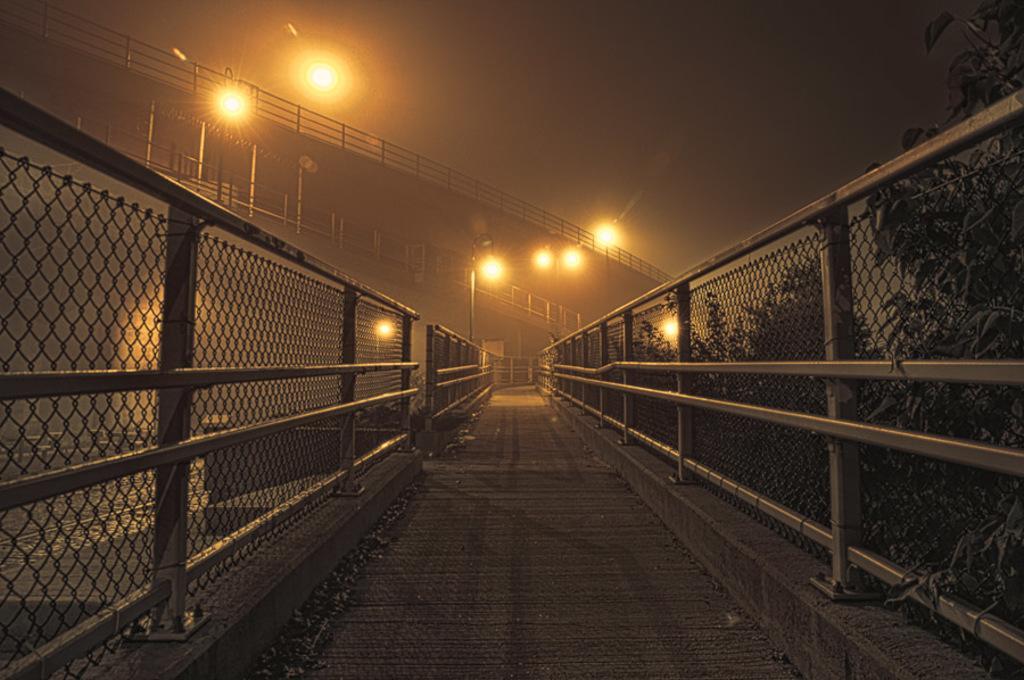Could you give a brief overview of what you see in this image? There is a road with fencing and rods are there on it. On the right side there are trees. In the back there are light poles and bridges with railings. 